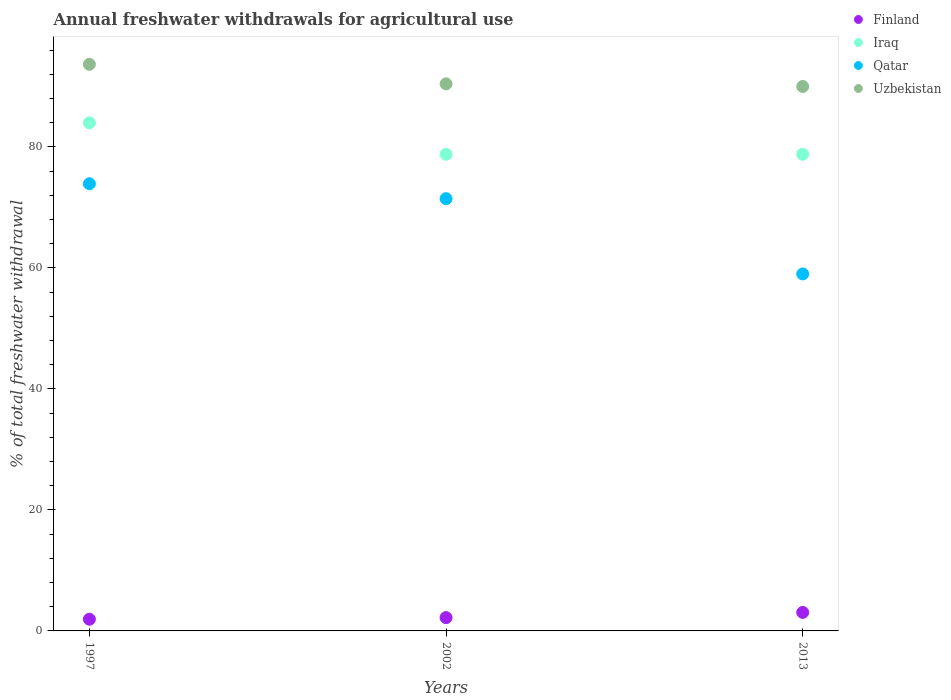Is the number of dotlines equal to the number of legend labels?
Provide a short and direct response. Yes. What is the total annual withdrawals from freshwater in Qatar in 2013?
Your answer should be very brief. 59.01. Across all years, what is the maximum total annual withdrawals from freshwater in Qatar?
Offer a terse response. 73.92. Across all years, what is the minimum total annual withdrawals from freshwater in Uzbekistan?
Your response must be concise. 90. In which year was the total annual withdrawals from freshwater in Uzbekistan maximum?
Your answer should be compact. 1997. In which year was the total annual withdrawals from freshwater in Finland minimum?
Provide a short and direct response. 1997. What is the total total annual withdrawals from freshwater in Finland in the graph?
Your response must be concise. 7.2. What is the difference between the total annual withdrawals from freshwater in Finland in 1997 and that in 2013?
Offer a terse response. -1.13. What is the difference between the total annual withdrawals from freshwater in Qatar in 2002 and the total annual withdrawals from freshwater in Uzbekistan in 2013?
Ensure brevity in your answer.  -18.55. What is the average total annual withdrawals from freshwater in Finland per year?
Your response must be concise. 2.4. In the year 2002, what is the difference between the total annual withdrawals from freshwater in Iraq and total annual withdrawals from freshwater in Uzbekistan?
Provide a short and direct response. -11.64. What is the ratio of the total annual withdrawals from freshwater in Finland in 1997 to that in 2002?
Ensure brevity in your answer.  0.88. Is the difference between the total annual withdrawals from freshwater in Iraq in 1997 and 2002 greater than the difference between the total annual withdrawals from freshwater in Uzbekistan in 1997 and 2002?
Offer a very short reply. Yes. What is the difference between the highest and the second highest total annual withdrawals from freshwater in Iraq?
Give a very brief answer. 5.2. What is the difference between the highest and the lowest total annual withdrawals from freshwater in Iraq?
Your response must be concise. 5.2. Is the sum of the total annual withdrawals from freshwater in Uzbekistan in 1997 and 2013 greater than the maximum total annual withdrawals from freshwater in Qatar across all years?
Keep it short and to the point. Yes. Is it the case that in every year, the sum of the total annual withdrawals from freshwater in Iraq and total annual withdrawals from freshwater in Qatar  is greater than the sum of total annual withdrawals from freshwater in Uzbekistan and total annual withdrawals from freshwater in Finland?
Provide a short and direct response. No. Is it the case that in every year, the sum of the total annual withdrawals from freshwater in Uzbekistan and total annual withdrawals from freshwater in Qatar  is greater than the total annual withdrawals from freshwater in Finland?
Ensure brevity in your answer.  Yes. Is the total annual withdrawals from freshwater in Uzbekistan strictly greater than the total annual withdrawals from freshwater in Iraq over the years?
Make the answer very short. Yes. Is the total annual withdrawals from freshwater in Uzbekistan strictly less than the total annual withdrawals from freshwater in Finland over the years?
Give a very brief answer. No. How many dotlines are there?
Provide a short and direct response. 4. Are the values on the major ticks of Y-axis written in scientific E-notation?
Make the answer very short. No. Does the graph contain any zero values?
Offer a very short reply. No. Where does the legend appear in the graph?
Offer a very short reply. Top right. What is the title of the graph?
Your response must be concise. Annual freshwater withdrawals for agricultural use. Does "Kenya" appear as one of the legend labels in the graph?
Offer a very short reply. No. What is the label or title of the X-axis?
Your answer should be very brief. Years. What is the label or title of the Y-axis?
Provide a short and direct response. % of total freshwater withdrawal. What is the % of total freshwater withdrawal in Finland in 1997?
Your answer should be very brief. 1.93. What is the % of total freshwater withdrawal in Iraq in 1997?
Your answer should be compact. 83.99. What is the % of total freshwater withdrawal in Qatar in 1997?
Your answer should be compact. 73.92. What is the % of total freshwater withdrawal in Uzbekistan in 1997?
Give a very brief answer. 93.66. What is the % of total freshwater withdrawal in Finland in 2002?
Your response must be concise. 2.2. What is the % of total freshwater withdrawal of Iraq in 2002?
Give a very brief answer. 78.79. What is the % of total freshwater withdrawal of Qatar in 2002?
Your response must be concise. 71.45. What is the % of total freshwater withdrawal in Uzbekistan in 2002?
Offer a very short reply. 90.43. What is the % of total freshwater withdrawal of Finland in 2013?
Give a very brief answer. 3.06. What is the % of total freshwater withdrawal in Iraq in 2013?
Offer a very short reply. 78.79. What is the % of total freshwater withdrawal in Qatar in 2013?
Your answer should be very brief. 59.01. Across all years, what is the maximum % of total freshwater withdrawal in Finland?
Ensure brevity in your answer.  3.06. Across all years, what is the maximum % of total freshwater withdrawal of Iraq?
Your answer should be very brief. 83.99. Across all years, what is the maximum % of total freshwater withdrawal in Qatar?
Give a very brief answer. 73.92. Across all years, what is the maximum % of total freshwater withdrawal in Uzbekistan?
Your answer should be compact. 93.66. Across all years, what is the minimum % of total freshwater withdrawal in Finland?
Ensure brevity in your answer.  1.93. Across all years, what is the minimum % of total freshwater withdrawal of Iraq?
Your answer should be very brief. 78.79. Across all years, what is the minimum % of total freshwater withdrawal in Qatar?
Offer a terse response. 59.01. Across all years, what is the minimum % of total freshwater withdrawal of Uzbekistan?
Provide a short and direct response. 90. What is the total % of total freshwater withdrawal in Finland in the graph?
Your answer should be compact. 7.2. What is the total % of total freshwater withdrawal in Iraq in the graph?
Ensure brevity in your answer.  241.57. What is the total % of total freshwater withdrawal of Qatar in the graph?
Offer a terse response. 204.38. What is the total % of total freshwater withdrawal in Uzbekistan in the graph?
Ensure brevity in your answer.  274.09. What is the difference between the % of total freshwater withdrawal of Finland in 1997 and that in 2002?
Your answer should be very brief. -0.27. What is the difference between the % of total freshwater withdrawal of Qatar in 1997 and that in 2002?
Give a very brief answer. 2.47. What is the difference between the % of total freshwater withdrawal in Uzbekistan in 1997 and that in 2002?
Make the answer very short. 3.23. What is the difference between the % of total freshwater withdrawal in Finland in 1997 and that in 2013?
Keep it short and to the point. -1.13. What is the difference between the % of total freshwater withdrawal in Qatar in 1997 and that in 2013?
Offer a terse response. 14.91. What is the difference between the % of total freshwater withdrawal of Uzbekistan in 1997 and that in 2013?
Provide a short and direct response. 3.66. What is the difference between the % of total freshwater withdrawal of Finland in 2002 and that in 2013?
Your answer should be very brief. -0.86. What is the difference between the % of total freshwater withdrawal in Qatar in 2002 and that in 2013?
Your answer should be very brief. 12.44. What is the difference between the % of total freshwater withdrawal of Uzbekistan in 2002 and that in 2013?
Your answer should be compact. 0.43. What is the difference between the % of total freshwater withdrawal in Finland in 1997 and the % of total freshwater withdrawal in Iraq in 2002?
Your answer should be very brief. -76.86. What is the difference between the % of total freshwater withdrawal of Finland in 1997 and the % of total freshwater withdrawal of Qatar in 2002?
Offer a very short reply. -69.52. What is the difference between the % of total freshwater withdrawal in Finland in 1997 and the % of total freshwater withdrawal in Uzbekistan in 2002?
Give a very brief answer. -88.5. What is the difference between the % of total freshwater withdrawal of Iraq in 1997 and the % of total freshwater withdrawal of Qatar in 2002?
Give a very brief answer. 12.54. What is the difference between the % of total freshwater withdrawal in Iraq in 1997 and the % of total freshwater withdrawal in Uzbekistan in 2002?
Ensure brevity in your answer.  -6.44. What is the difference between the % of total freshwater withdrawal of Qatar in 1997 and the % of total freshwater withdrawal of Uzbekistan in 2002?
Ensure brevity in your answer.  -16.51. What is the difference between the % of total freshwater withdrawal of Finland in 1997 and the % of total freshwater withdrawal of Iraq in 2013?
Offer a very short reply. -76.86. What is the difference between the % of total freshwater withdrawal of Finland in 1997 and the % of total freshwater withdrawal of Qatar in 2013?
Make the answer very short. -57.08. What is the difference between the % of total freshwater withdrawal in Finland in 1997 and the % of total freshwater withdrawal in Uzbekistan in 2013?
Offer a terse response. -88.07. What is the difference between the % of total freshwater withdrawal in Iraq in 1997 and the % of total freshwater withdrawal in Qatar in 2013?
Your answer should be compact. 24.98. What is the difference between the % of total freshwater withdrawal of Iraq in 1997 and the % of total freshwater withdrawal of Uzbekistan in 2013?
Your answer should be compact. -6.01. What is the difference between the % of total freshwater withdrawal in Qatar in 1997 and the % of total freshwater withdrawal in Uzbekistan in 2013?
Your answer should be compact. -16.08. What is the difference between the % of total freshwater withdrawal of Finland in 2002 and the % of total freshwater withdrawal of Iraq in 2013?
Keep it short and to the point. -76.59. What is the difference between the % of total freshwater withdrawal in Finland in 2002 and the % of total freshwater withdrawal in Qatar in 2013?
Your answer should be compact. -56.81. What is the difference between the % of total freshwater withdrawal in Finland in 2002 and the % of total freshwater withdrawal in Uzbekistan in 2013?
Your answer should be compact. -87.8. What is the difference between the % of total freshwater withdrawal of Iraq in 2002 and the % of total freshwater withdrawal of Qatar in 2013?
Your response must be concise. 19.78. What is the difference between the % of total freshwater withdrawal of Iraq in 2002 and the % of total freshwater withdrawal of Uzbekistan in 2013?
Offer a very short reply. -11.21. What is the difference between the % of total freshwater withdrawal in Qatar in 2002 and the % of total freshwater withdrawal in Uzbekistan in 2013?
Offer a terse response. -18.55. What is the average % of total freshwater withdrawal of Finland per year?
Provide a succinct answer. 2.4. What is the average % of total freshwater withdrawal in Iraq per year?
Make the answer very short. 80.52. What is the average % of total freshwater withdrawal of Qatar per year?
Make the answer very short. 68.13. What is the average % of total freshwater withdrawal of Uzbekistan per year?
Provide a succinct answer. 91.36. In the year 1997, what is the difference between the % of total freshwater withdrawal in Finland and % of total freshwater withdrawal in Iraq?
Keep it short and to the point. -82.06. In the year 1997, what is the difference between the % of total freshwater withdrawal of Finland and % of total freshwater withdrawal of Qatar?
Your answer should be very brief. -71.99. In the year 1997, what is the difference between the % of total freshwater withdrawal of Finland and % of total freshwater withdrawal of Uzbekistan?
Provide a succinct answer. -91.73. In the year 1997, what is the difference between the % of total freshwater withdrawal of Iraq and % of total freshwater withdrawal of Qatar?
Make the answer very short. 10.07. In the year 1997, what is the difference between the % of total freshwater withdrawal in Iraq and % of total freshwater withdrawal in Uzbekistan?
Offer a very short reply. -9.67. In the year 1997, what is the difference between the % of total freshwater withdrawal of Qatar and % of total freshwater withdrawal of Uzbekistan?
Offer a very short reply. -19.74. In the year 2002, what is the difference between the % of total freshwater withdrawal of Finland and % of total freshwater withdrawal of Iraq?
Provide a short and direct response. -76.59. In the year 2002, what is the difference between the % of total freshwater withdrawal of Finland and % of total freshwater withdrawal of Qatar?
Your answer should be very brief. -69.25. In the year 2002, what is the difference between the % of total freshwater withdrawal in Finland and % of total freshwater withdrawal in Uzbekistan?
Provide a short and direct response. -88.23. In the year 2002, what is the difference between the % of total freshwater withdrawal of Iraq and % of total freshwater withdrawal of Qatar?
Offer a very short reply. 7.34. In the year 2002, what is the difference between the % of total freshwater withdrawal in Iraq and % of total freshwater withdrawal in Uzbekistan?
Your answer should be compact. -11.64. In the year 2002, what is the difference between the % of total freshwater withdrawal of Qatar and % of total freshwater withdrawal of Uzbekistan?
Offer a terse response. -18.98. In the year 2013, what is the difference between the % of total freshwater withdrawal in Finland and % of total freshwater withdrawal in Iraq?
Ensure brevity in your answer.  -75.73. In the year 2013, what is the difference between the % of total freshwater withdrawal in Finland and % of total freshwater withdrawal in Qatar?
Make the answer very short. -55.95. In the year 2013, what is the difference between the % of total freshwater withdrawal in Finland and % of total freshwater withdrawal in Uzbekistan?
Offer a terse response. -86.94. In the year 2013, what is the difference between the % of total freshwater withdrawal in Iraq and % of total freshwater withdrawal in Qatar?
Offer a very short reply. 19.78. In the year 2013, what is the difference between the % of total freshwater withdrawal of Iraq and % of total freshwater withdrawal of Uzbekistan?
Keep it short and to the point. -11.21. In the year 2013, what is the difference between the % of total freshwater withdrawal of Qatar and % of total freshwater withdrawal of Uzbekistan?
Ensure brevity in your answer.  -30.99. What is the ratio of the % of total freshwater withdrawal of Finland in 1997 to that in 2002?
Provide a short and direct response. 0.88. What is the ratio of the % of total freshwater withdrawal of Iraq in 1997 to that in 2002?
Your response must be concise. 1.07. What is the ratio of the % of total freshwater withdrawal of Qatar in 1997 to that in 2002?
Ensure brevity in your answer.  1.03. What is the ratio of the % of total freshwater withdrawal in Uzbekistan in 1997 to that in 2002?
Your answer should be very brief. 1.04. What is the ratio of the % of total freshwater withdrawal in Finland in 1997 to that in 2013?
Make the answer very short. 0.63. What is the ratio of the % of total freshwater withdrawal in Iraq in 1997 to that in 2013?
Give a very brief answer. 1.07. What is the ratio of the % of total freshwater withdrawal of Qatar in 1997 to that in 2013?
Your answer should be very brief. 1.25. What is the ratio of the % of total freshwater withdrawal of Uzbekistan in 1997 to that in 2013?
Your answer should be compact. 1.04. What is the ratio of the % of total freshwater withdrawal of Finland in 2002 to that in 2013?
Keep it short and to the point. 0.72. What is the ratio of the % of total freshwater withdrawal of Qatar in 2002 to that in 2013?
Provide a succinct answer. 1.21. What is the ratio of the % of total freshwater withdrawal of Uzbekistan in 2002 to that in 2013?
Offer a terse response. 1. What is the difference between the highest and the second highest % of total freshwater withdrawal in Finland?
Provide a succinct answer. 0.86. What is the difference between the highest and the second highest % of total freshwater withdrawal of Iraq?
Make the answer very short. 5.2. What is the difference between the highest and the second highest % of total freshwater withdrawal of Qatar?
Offer a very short reply. 2.47. What is the difference between the highest and the second highest % of total freshwater withdrawal of Uzbekistan?
Make the answer very short. 3.23. What is the difference between the highest and the lowest % of total freshwater withdrawal of Finland?
Your response must be concise. 1.13. What is the difference between the highest and the lowest % of total freshwater withdrawal in Qatar?
Your answer should be very brief. 14.91. What is the difference between the highest and the lowest % of total freshwater withdrawal of Uzbekistan?
Ensure brevity in your answer.  3.66. 